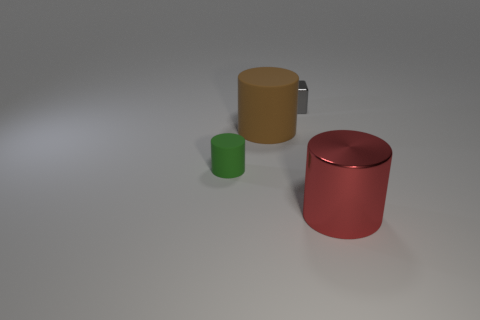Is the size of the red cylinder the same as the metal object behind the big red object?
Give a very brief answer. No. Is there anything else that has the same shape as the gray thing?
Make the answer very short. No. What number of things are there?
Keep it short and to the point. 4. How many yellow objects are shiny cubes or small matte cylinders?
Keep it short and to the point. 0. Do the big cylinder that is left of the tiny shiny cube and the red object have the same material?
Keep it short and to the point. No. How many other things are the same material as the small gray block?
Offer a very short reply. 1. What material is the brown cylinder?
Provide a succinct answer. Rubber. What is the size of the metallic thing that is behind the big shiny cylinder?
Provide a short and direct response. Small. What number of cylinders are on the left side of the shiny object on the left side of the big shiny cylinder?
Offer a very short reply. 2. There is a metallic thing in front of the shiny block; does it have the same shape as the matte object left of the large matte cylinder?
Keep it short and to the point. Yes. 